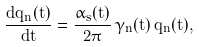<formula> <loc_0><loc_0><loc_500><loc_500>\frac { d \bar { q } _ { n } ( t ) } { d t } = \frac { \alpha _ { s } ( t ) } { 2 \pi } \, \gamma _ { n } ( t ) \, \bar { q } _ { n } ( t ) ,</formula> 